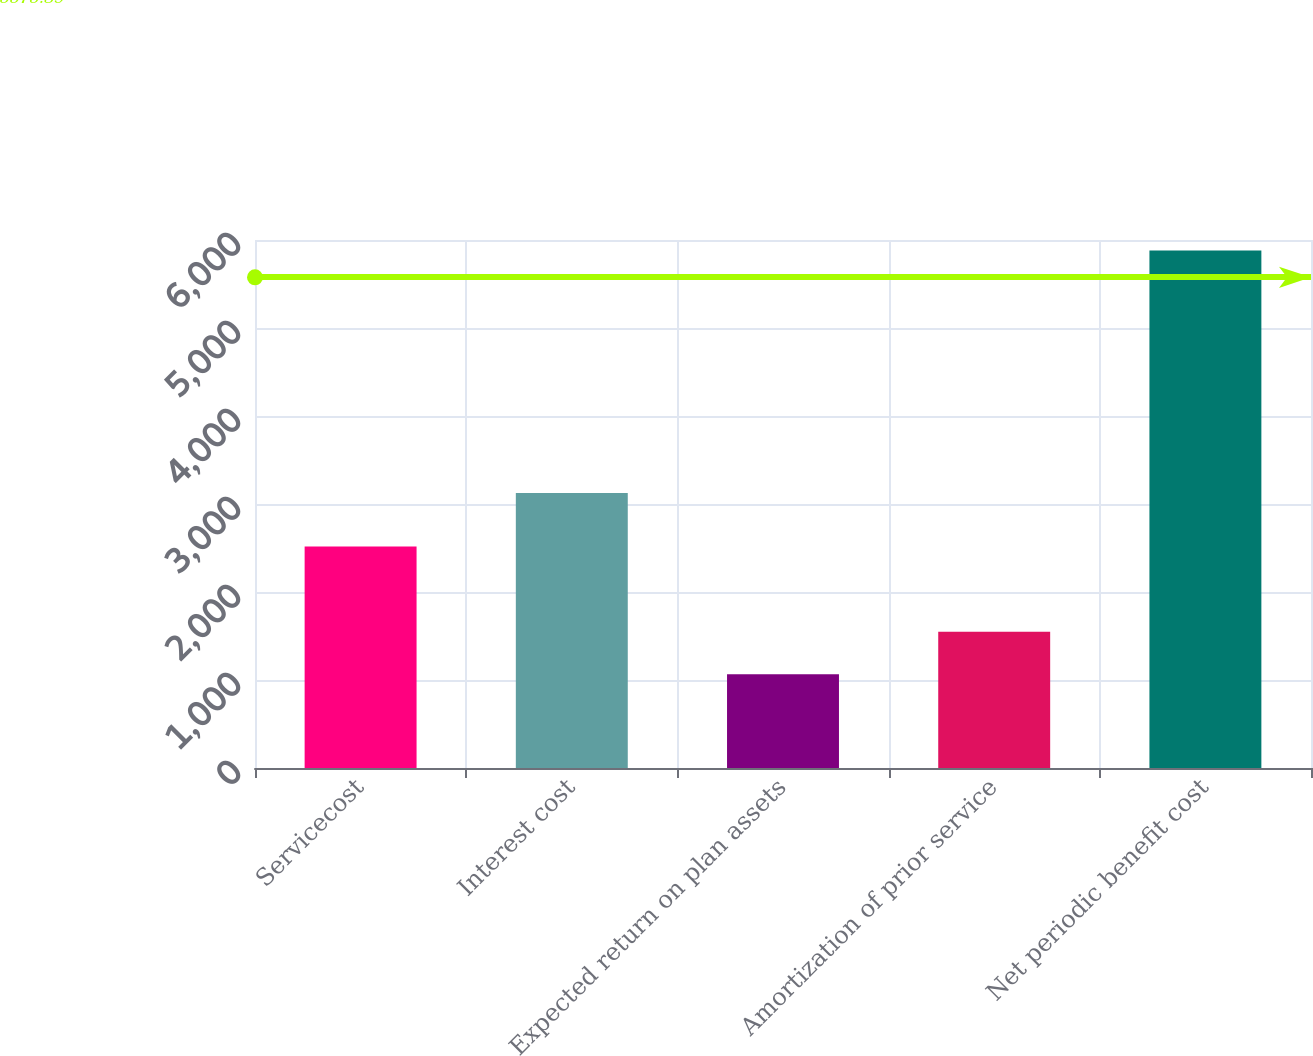Convert chart to OTSL. <chart><loc_0><loc_0><loc_500><loc_500><bar_chart><fcel>Servicecost<fcel>Interest cost<fcel>Expected return on plan assets<fcel>Amortization of prior service<fcel>Net periodic benefit cost<nl><fcel>2516<fcel>3125<fcel>1066<fcel>1547.6<fcel>5882<nl></chart> 